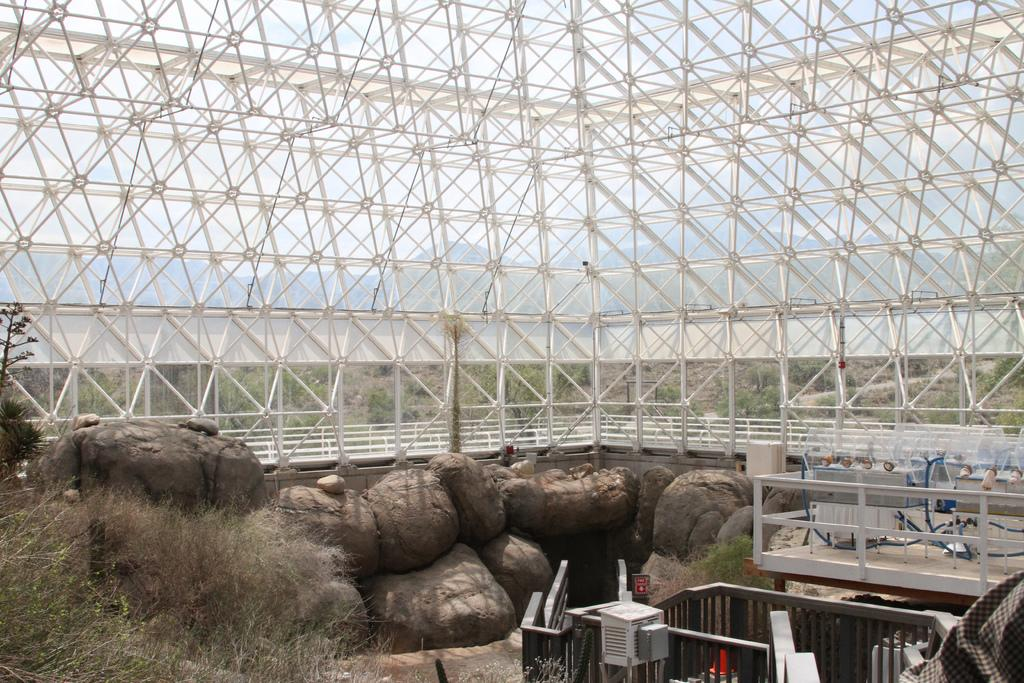What type of natural elements can be seen in the image? There are stones and plants visible in the image. What man-made objects can be seen in the image? There are rods and some objects visible in the image. What is visible in the background of the image? Mountains and the sky are visible in the background of the image. Can you see any laborers working on the tracks in the image? There are no laborers or tracks present in the image. What type of cracker is being used to build the structure in the image? There is no cracker present in the image, and no structure is being built. 